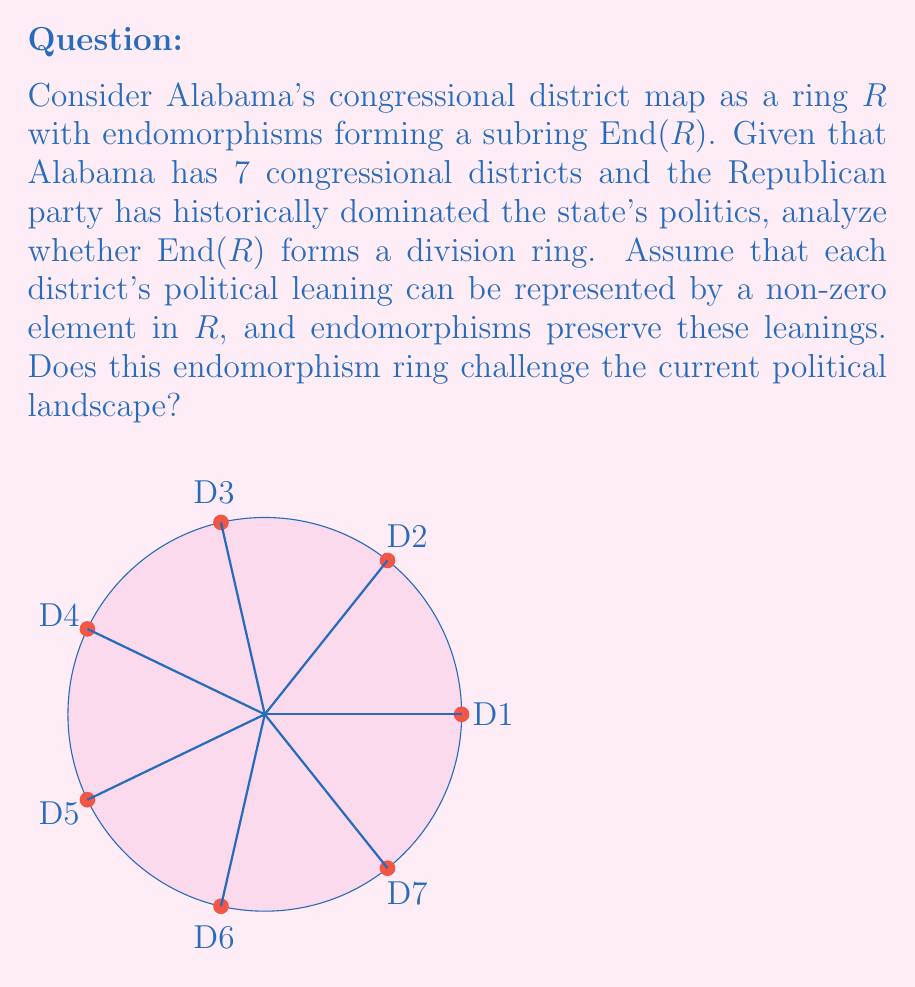What is the answer to this math problem? Let's approach this step-by-step:

1) First, recall that a division ring is a ring where every non-zero element has a multiplicative inverse.

2) In our context, $R$ represents Alabama's congressional district map, and $End(R)$ is the ring of endomorphisms on $R$.

3) For $End(R)$ to be a division ring, every non-zero endomorphism must have an inverse that is also an endomorphism.

4) Given that Alabama has 7 districts, $R$ has 7 non-zero elements. Let's denote them as $\{r_1, r_2, ..., r_7\}$.

5) An endomorphism $f \in End(R)$ must preserve the structure of $R$. In political terms, it should maintain the relative political leanings of the districts.

6) The Republican dominance in Alabama suggests that most endomorphisms would map most districts to Republican-leaning outcomes. Mathematically, this means many endomorphisms would map multiple elements of $R$ to the same element.

7) For example, an endomorphism $f$ might look like:
   $f(r_1) = f(r_2) = f(r_3) = f(r_4) = f(r_5) = f(r_6) = r_7$ (Republican)
   $f(r_7) = r_1$ (potentially Democratic)

8) This endomorphism is not bijective, as it's not one-to-one. Therefore, it doesn't have an inverse in $End(R)$.

9) The existence of such non-invertible endomorphisms means that $End(R)$ cannot be a division ring.

10) From a political perspective, this reflects the difficulty in creating a balanced or competitive district map in a state dominated by one party.
Answer: No, $End(R)$ is not a division ring. 